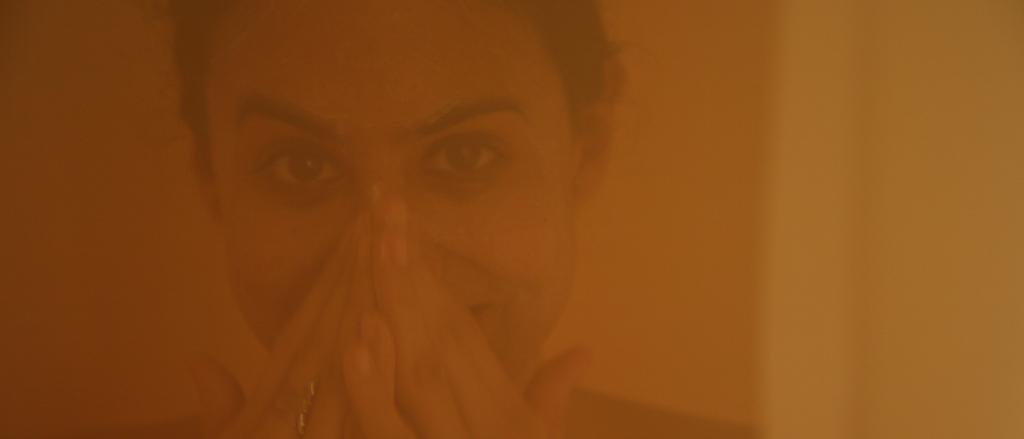Can you describe this image briefly? In this image I can see the person's face. I can see the image is in orange and yellow color. 